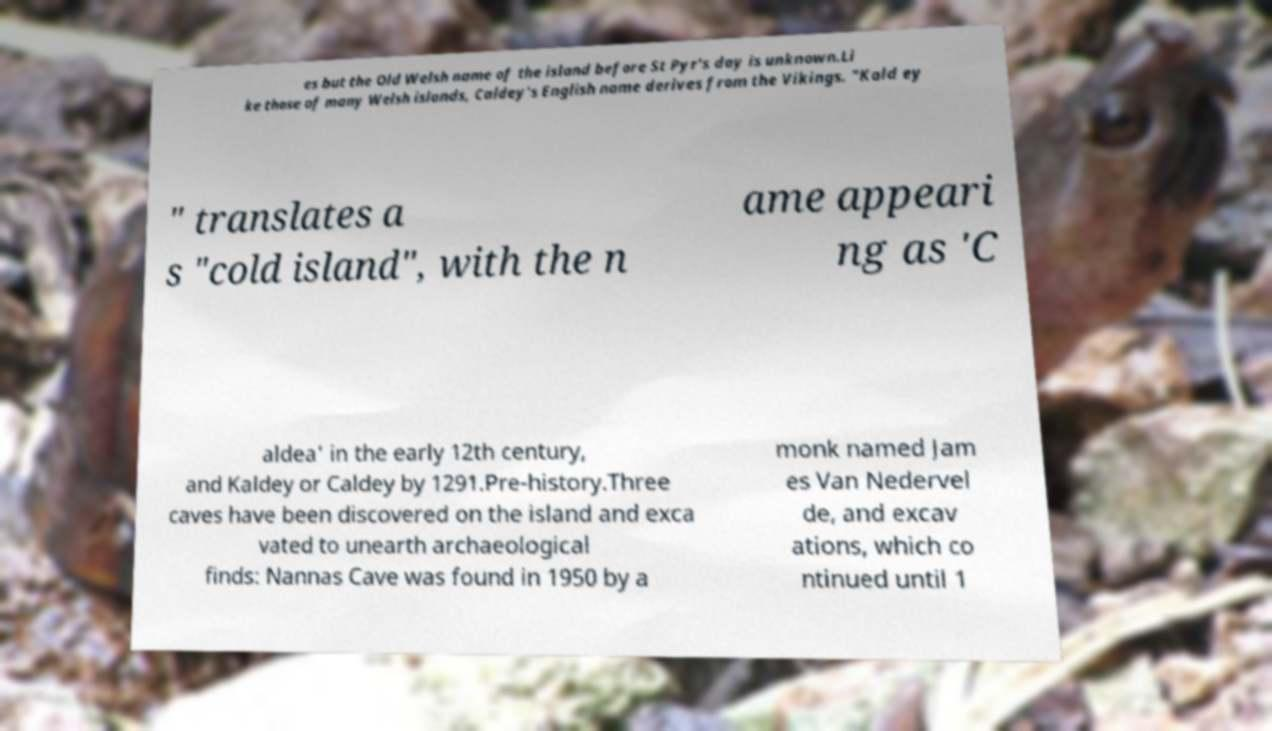For documentation purposes, I need the text within this image transcribed. Could you provide that? es but the Old Welsh name of the island before St Pyr's day is unknown.Li ke those of many Welsh islands, Caldey's English name derives from the Vikings. "Kald ey " translates a s "cold island", with the n ame appeari ng as 'C aldea' in the early 12th century, and Kaldey or Caldey by 1291.Pre-history.Three caves have been discovered on the island and exca vated to unearth archaeological finds: Nannas Cave was found in 1950 by a monk named Jam es Van Nedervel de, and excav ations, which co ntinued until 1 